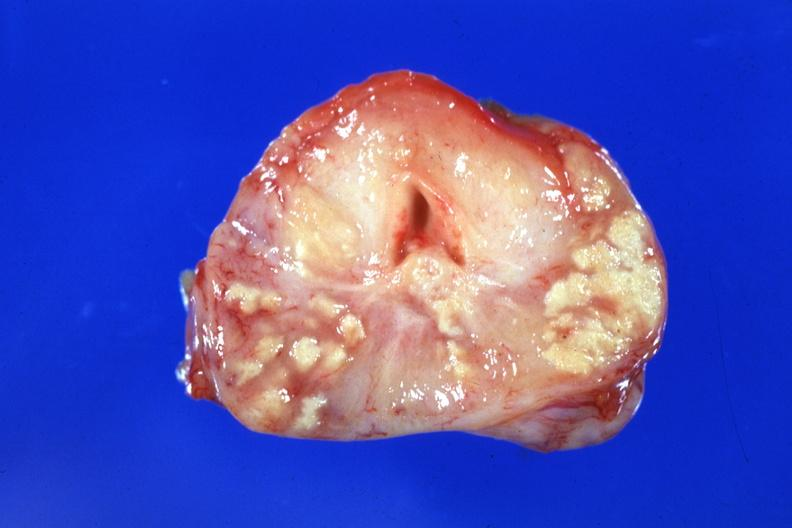does this image show large caseous lesions easily seen excellent example?
Answer the question using a single word or phrase. Yes 